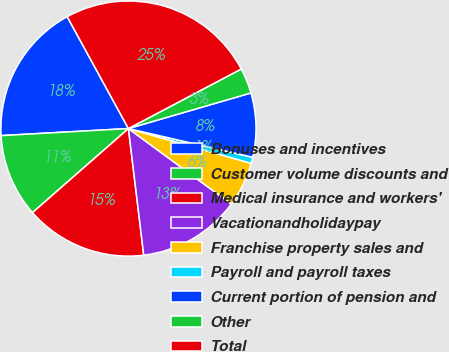Convert chart to OTSL. <chart><loc_0><loc_0><loc_500><loc_500><pie_chart><fcel>Bonuses and incentives<fcel>Customer volume discounts and<fcel>Medical insurance and workers'<fcel>Vacationandholidaypay<fcel>Franchise property sales and<fcel>Payroll and payroll taxes<fcel>Current portion of pension and<fcel>Other<fcel>Total<nl><fcel>17.91%<fcel>10.57%<fcel>15.46%<fcel>13.01%<fcel>5.68%<fcel>0.78%<fcel>8.12%<fcel>3.23%<fcel>25.24%<nl></chart> 